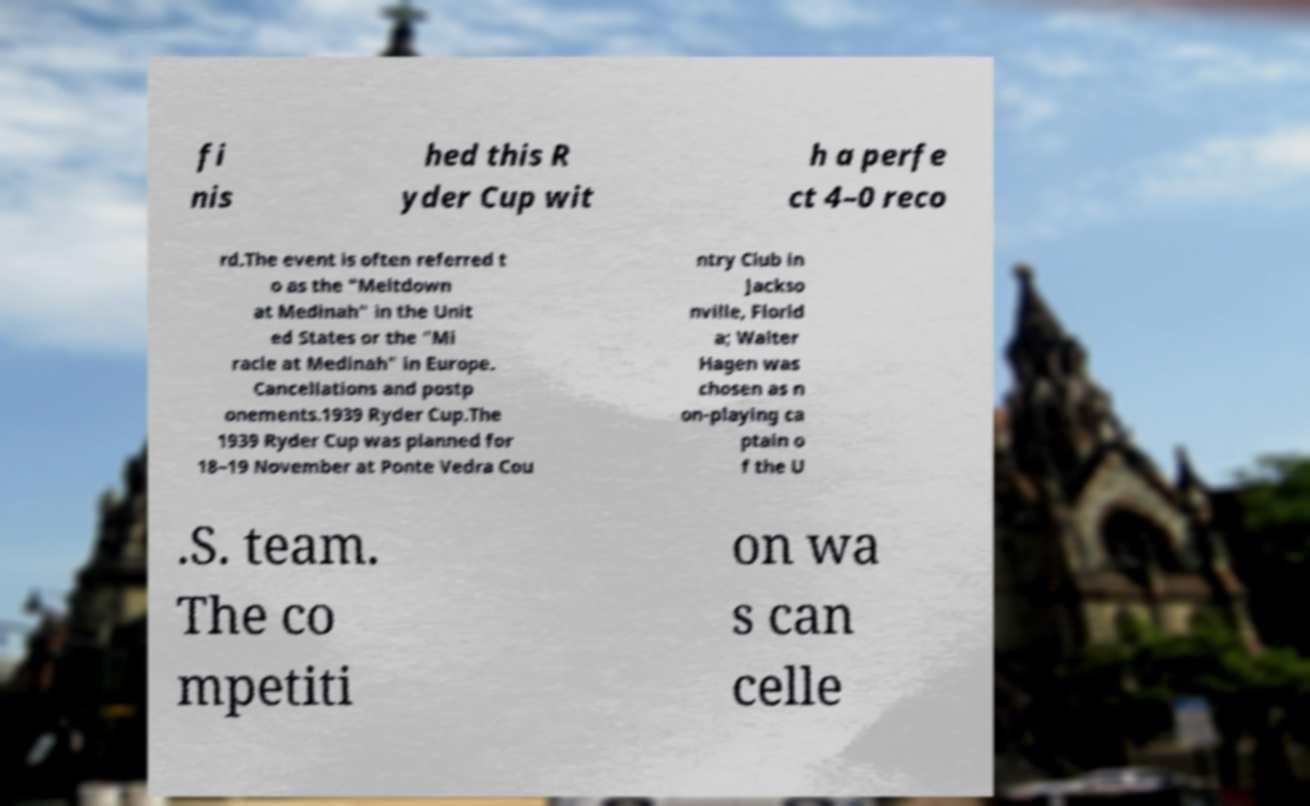Please identify and transcribe the text found in this image. fi nis hed this R yder Cup wit h a perfe ct 4–0 reco rd.The event is often referred t o as the "Meltdown at Medinah" in the Unit ed States or the "Mi racle at Medinah" in Europe. Cancellations and postp onements.1939 Ryder Cup.The 1939 Ryder Cup was planned for 18–19 November at Ponte Vedra Cou ntry Club in Jackso nville, Florid a; Walter Hagen was chosen as n on-playing ca ptain o f the U .S. team. The co mpetiti on wa s can celle 